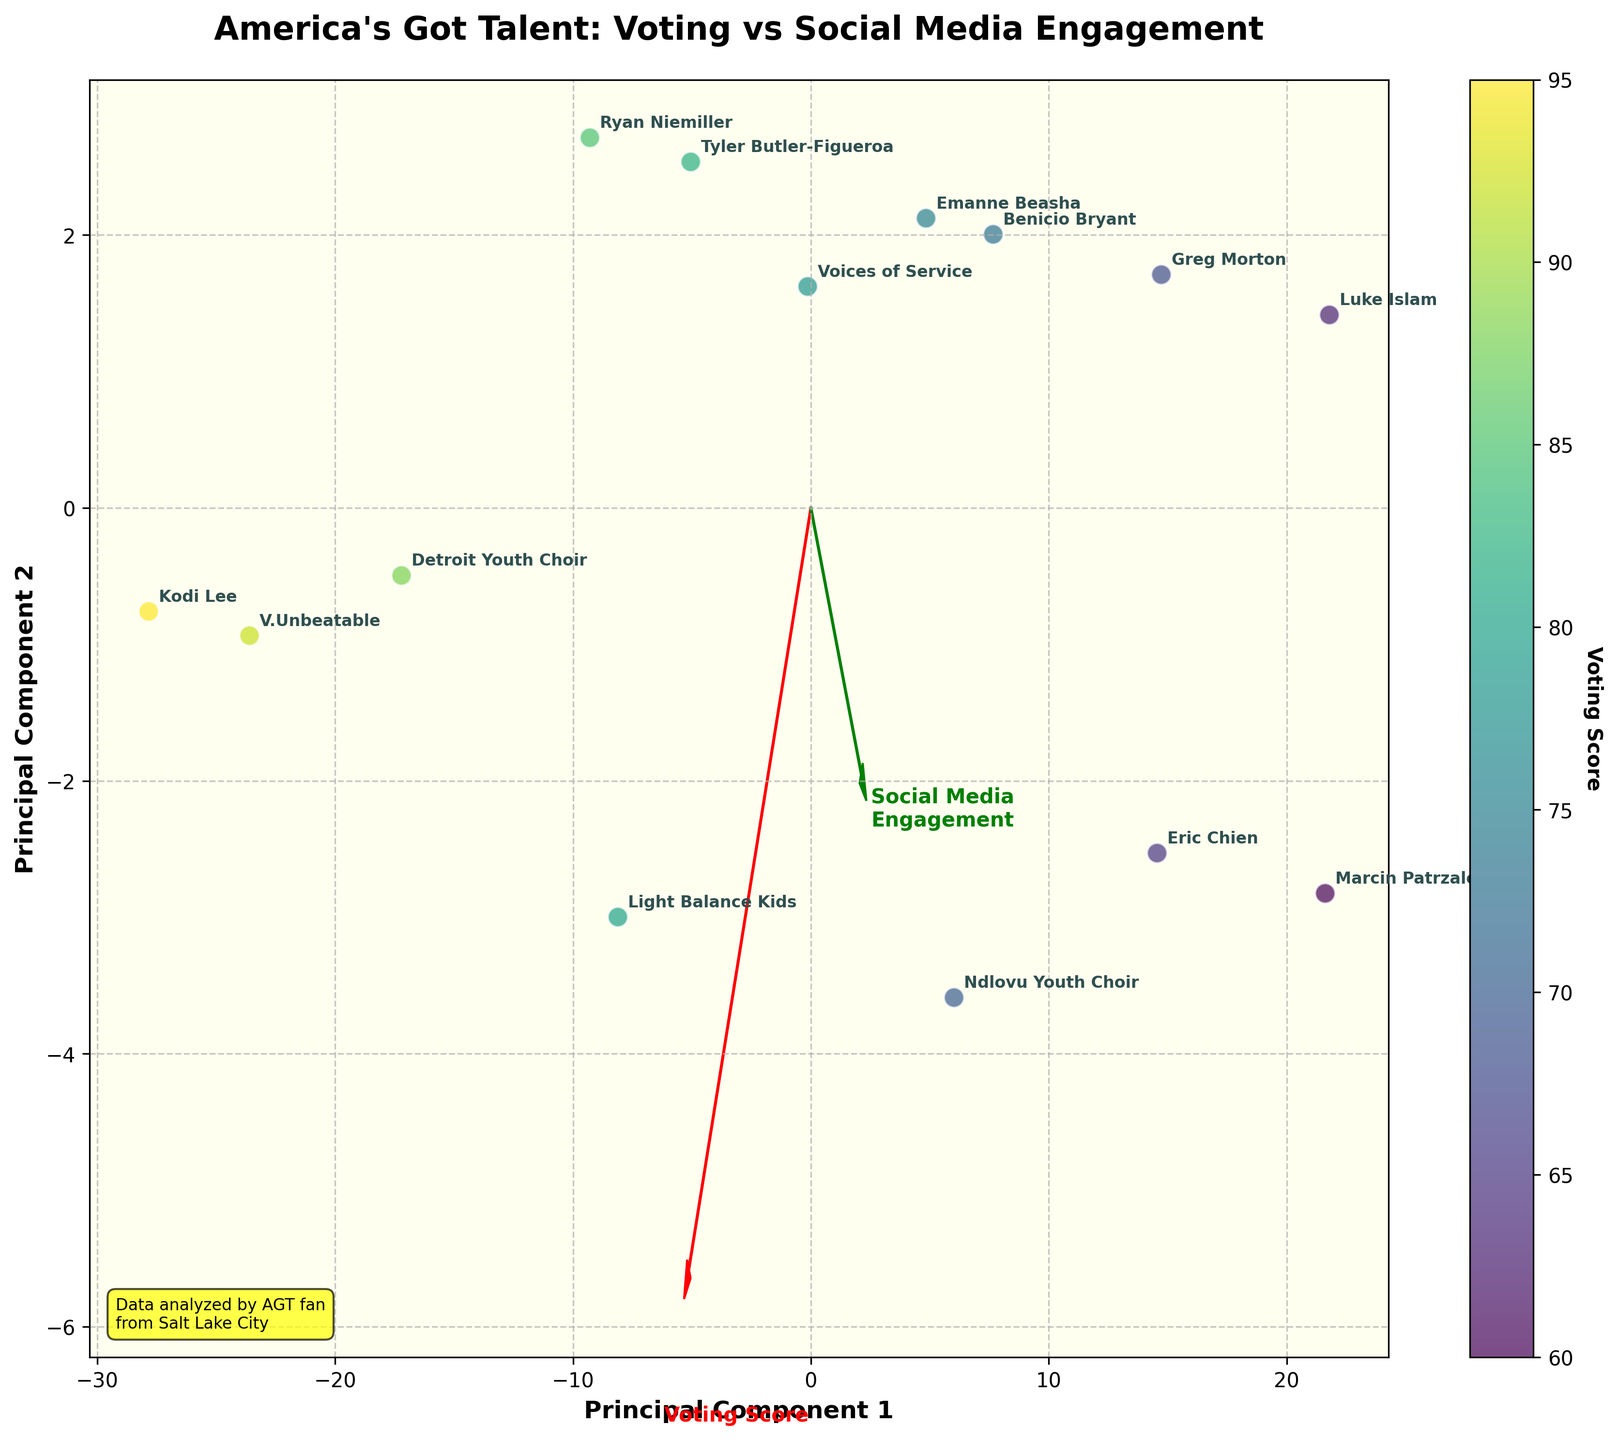What is the title of the figure? The title of the figure is displayed at the top in bold, indicating the theme of the data visualized in the plot.
Answer: America's Got Talent: Voting vs Social Media Engagement Which Principal Component corresponds to Voting Score? The Voting Score is indicated by the red arrow pointing in the direction of its influence. The arrow labeled 'Voting Score' corresponds to the first Principal Component.
Answer: Principal Component 1 How many data points are there in the plot? Each act represents one data point in the plot. Count the number of acts labeled in the figure to get the total. There are 14 acts listed.
Answer: 14 Which act has the highest Social Media Engagement? Look at the labels and their positions relative to the green arrow (Social Media Engagement). The act farthest in the direction of the green arrow has the highest engagement.
Answer: Kodi Lee Which Principal Component has more influence from Social Media Engagement? The arrows represent the influence of the original variables on the Principal Components. Compare the green arrow (Social Media Engagement) directions; it corresponds to Principal Component 2.
Answer: Principal Component 2 Which two acts have nearly equal Social Media Engagement? Examine the proximity of the points along the direction of the green arrow (Social Media Engagement) to find two close together.
Answer: Emanne Beasha and Benicio Bryant Are the acts with the highest Voting Scores also the highest in Social Media Engagement? Check if the points with the highest Voting Scores (indicated by the color gradient) are positioned far along the green arrow for Social Media Engagement.
Answer: Yes What is the range of Voting Scores represented in the color gradient? Refer to the color gradient bar on the right, which categorizes the Voting Scores from the lowest to the highest value. The values range from 60 to 95.
Answer: 60 to 95 Is there a strong correlation between Voting Score and Social Media Engagement? Evaluate the plot for a general trend where high Voting Scores (brighter yellow dots) are positioned towards high Social Media Engagement (along the green arrow). The overlap and proximity indicate a strong correlation.
Answer: Yes 